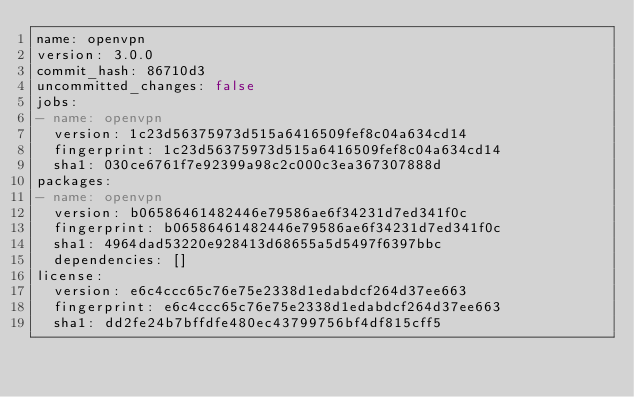Convert code to text. <code><loc_0><loc_0><loc_500><loc_500><_YAML_>name: openvpn
version: 3.0.0
commit_hash: 86710d3
uncommitted_changes: false
jobs:
- name: openvpn
  version: 1c23d56375973d515a6416509fef8c04a634cd14
  fingerprint: 1c23d56375973d515a6416509fef8c04a634cd14
  sha1: 030ce6761f7e92399a98c2c000c3ea367307888d
packages:
- name: openvpn
  version: b06586461482446e79586ae6f34231d7ed341f0c
  fingerprint: b06586461482446e79586ae6f34231d7ed341f0c
  sha1: 4964dad53220e928413d68655a5d5497f6397bbc
  dependencies: []
license:
  version: e6c4ccc65c76e75e2338d1edabdcf264d37ee663
  fingerprint: e6c4ccc65c76e75e2338d1edabdcf264d37ee663
  sha1: dd2fe24b7bffdfe480ec43799756bf4df815cff5
</code> 